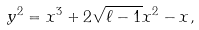Convert formula to latex. <formula><loc_0><loc_0><loc_500><loc_500>y ^ { 2 } = x ^ { 3 } + 2 \sqrt { \ell - 1 } x ^ { 2 } - x ,</formula> 